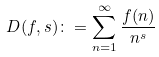<formula> <loc_0><loc_0><loc_500><loc_500>D ( f , s ) \colon = \sum _ { n = 1 } ^ { \infty } \frac { f ( n ) } { n ^ { s } }</formula> 